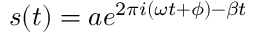Convert formula to latex. <formula><loc_0><loc_0><loc_500><loc_500>\begin{array} { r } { s ( t ) = a e ^ { 2 \pi i ( \omega t + \phi ) - \beta t } } \end{array}</formula> 